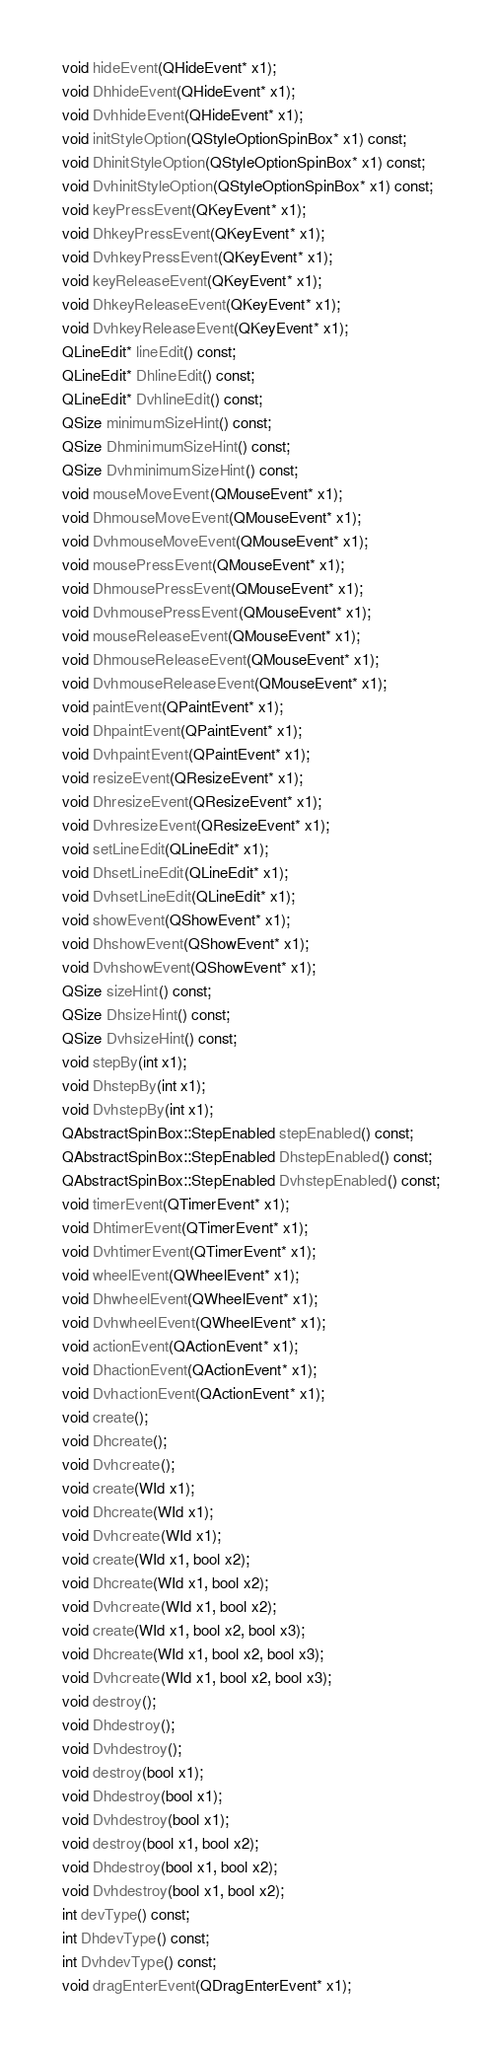Convert code to text. <code><loc_0><loc_0><loc_500><loc_500><_C_>  void hideEvent(QHideEvent* x1);
  void DhhideEvent(QHideEvent* x1);
  void DvhhideEvent(QHideEvent* x1);
  void initStyleOption(QStyleOptionSpinBox* x1) const;
  void DhinitStyleOption(QStyleOptionSpinBox* x1) const;
  void DvhinitStyleOption(QStyleOptionSpinBox* x1) const;
  void keyPressEvent(QKeyEvent* x1);
  void DhkeyPressEvent(QKeyEvent* x1);
  void DvhkeyPressEvent(QKeyEvent* x1);
  void keyReleaseEvent(QKeyEvent* x1);
  void DhkeyReleaseEvent(QKeyEvent* x1);
  void DvhkeyReleaseEvent(QKeyEvent* x1);
  QLineEdit* lineEdit() const;
  QLineEdit* DhlineEdit() const;
  QLineEdit* DvhlineEdit() const;
  QSize minimumSizeHint() const;
  QSize DhminimumSizeHint() const;
  QSize DvhminimumSizeHint() const;
  void mouseMoveEvent(QMouseEvent* x1);
  void DhmouseMoveEvent(QMouseEvent* x1);
  void DvhmouseMoveEvent(QMouseEvent* x1);
  void mousePressEvent(QMouseEvent* x1);
  void DhmousePressEvent(QMouseEvent* x1);
  void DvhmousePressEvent(QMouseEvent* x1);
  void mouseReleaseEvent(QMouseEvent* x1);
  void DhmouseReleaseEvent(QMouseEvent* x1);
  void DvhmouseReleaseEvent(QMouseEvent* x1);
  void paintEvent(QPaintEvent* x1);
  void DhpaintEvent(QPaintEvent* x1);
  void DvhpaintEvent(QPaintEvent* x1);
  void resizeEvent(QResizeEvent* x1);
  void DhresizeEvent(QResizeEvent* x1);
  void DvhresizeEvent(QResizeEvent* x1);
  void setLineEdit(QLineEdit* x1);
  void DhsetLineEdit(QLineEdit* x1);
  void DvhsetLineEdit(QLineEdit* x1);
  void showEvent(QShowEvent* x1);
  void DhshowEvent(QShowEvent* x1);
  void DvhshowEvent(QShowEvent* x1);
  QSize sizeHint() const;
  QSize DhsizeHint() const;
  QSize DvhsizeHint() const;
  void stepBy(int x1);
  void DhstepBy(int x1);
  void DvhstepBy(int x1);
  QAbstractSpinBox::StepEnabled stepEnabled() const;
  QAbstractSpinBox::StepEnabled DhstepEnabled() const;
  QAbstractSpinBox::StepEnabled DvhstepEnabled() const;
  void timerEvent(QTimerEvent* x1);
  void DhtimerEvent(QTimerEvent* x1);
  void DvhtimerEvent(QTimerEvent* x1);
  void wheelEvent(QWheelEvent* x1);
  void DhwheelEvent(QWheelEvent* x1);
  void DvhwheelEvent(QWheelEvent* x1);
  void actionEvent(QActionEvent* x1);
  void DhactionEvent(QActionEvent* x1);
  void DvhactionEvent(QActionEvent* x1);
  void create();
  void Dhcreate();
  void Dvhcreate();
  void create(WId x1);
  void Dhcreate(WId x1);
  void Dvhcreate(WId x1);
  void create(WId x1, bool x2);
  void Dhcreate(WId x1, bool x2);
  void Dvhcreate(WId x1, bool x2);
  void create(WId x1, bool x2, bool x3);
  void Dhcreate(WId x1, bool x2, bool x3);
  void Dvhcreate(WId x1, bool x2, bool x3);
  void destroy();
  void Dhdestroy();
  void Dvhdestroy();
  void destroy(bool x1);
  void Dhdestroy(bool x1);
  void Dvhdestroy(bool x1);
  void destroy(bool x1, bool x2);
  void Dhdestroy(bool x1, bool x2);
  void Dvhdestroy(bool x1, bool x2);
  int devType() const;
  int DhdevType() const;
  int DvhdevType() const;
  void dragEnterEvent(QDragEnterEvent* x1);</code> 